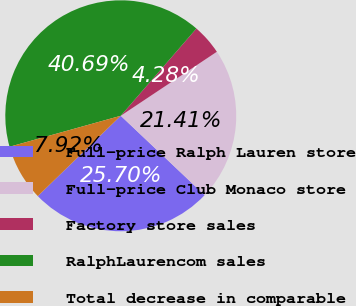Convert chart to OTSL. <chart><loc_0><loc_0><loc_500><loc_500><pie_chart><fcel>Full-price Ralph Lauren store<fcel>Full-price Club Monaco store<fcel>Factory store sales<fcel>RalphLaurencom sales<fcel>Total decrease in comparable<nl><fcel>25.7%<fcel>21.41%<fcel>4.28%<fcel>40.69%<fcel>7.92%<nl></chart> 